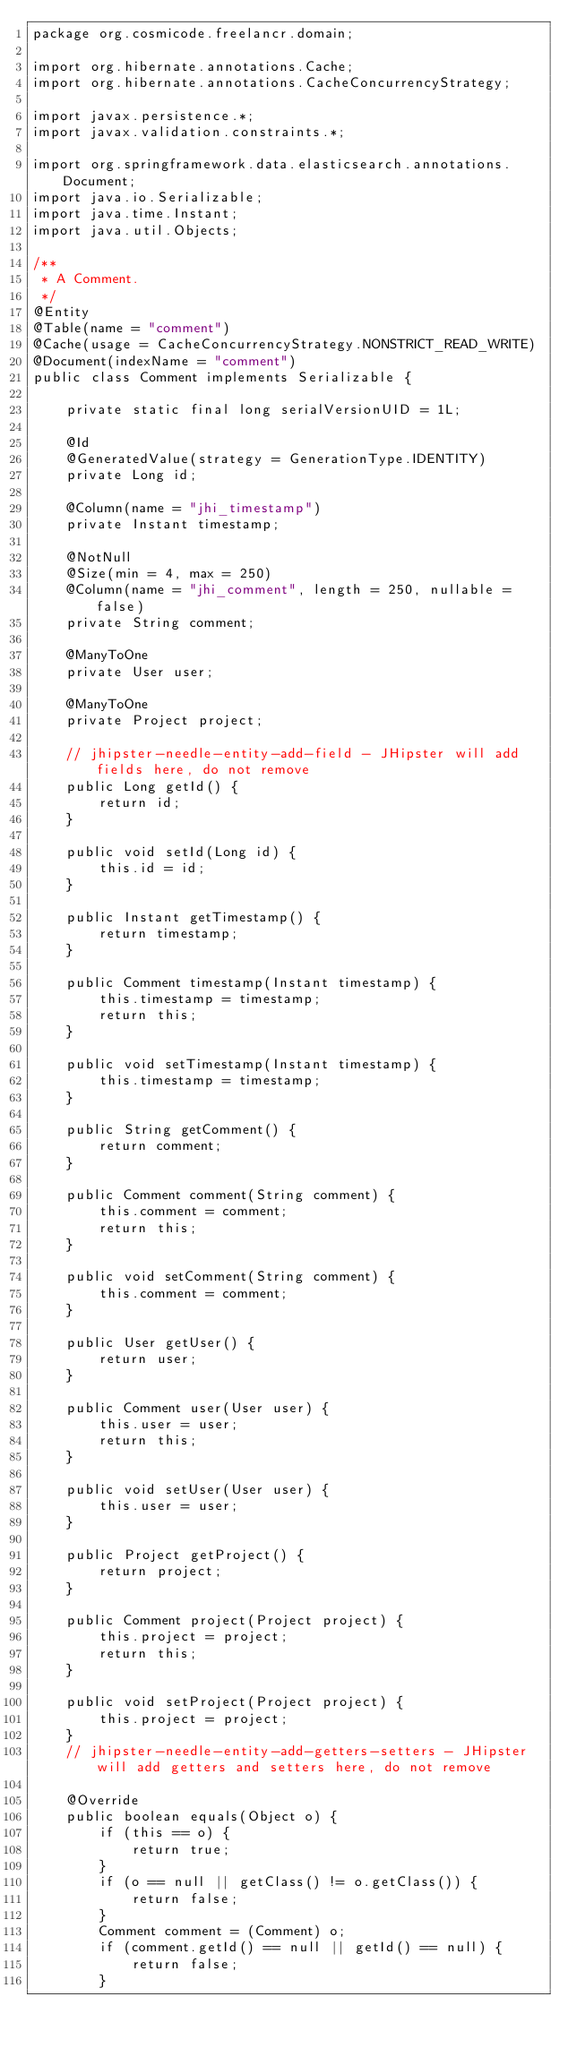Convert code to text. <code><loc_0><loc_0><loc_500><loc_500><_Java_>package org.cosmicode.freelancr.domain;

import org.hibernate.annotations.Cache;
import org.hibernate.annotations.CacheConcurrencyStrategy;

import javax.persistence.*;
import javax.validation.constraints.*;

import org.springframework.data.elasticsearch.annotations.Document;
import java.io.Serializable;
import java.time.Instant;
import java.util.Objects;

/**
 * A Comment.
 */
@Entity
@Table(name = "comment")
@Cache(usage = CacheConcurrencyStrategy.NONSTRICT_READ_WRITE)
@Document(indexName = "comment")
public class Comment implements Serializable {

    private static final long serialVersionUID = 1L;

    @Id
    @GeneratedValue(strategy = GenerationType.IDENTITY)
    private Long id;

    @Column(name = "jhi_timestamp")
    private Instant timestamp;

    @NotNull
    @Size(min = 4, max = 250)
    @Column(name = "jhi_comment", length = 250, nullable = false)
    private String comment;

    @ManyToOne
    private User user;

    @ManyToOne
    private Project project;

    // jhipster-needle-entity-add-field - JHipster will add fields here, do not remove
    public Long getId() {
        return id;
    }

    public void setId(Long id) {
        this.id = id;
    }

    public Instant getTimestamp() {
        return timestamp;
    }

    public Comment timestamp(Instant timestamp) {
        this.timestamp = timestamp;
        return this;
    }

    public void setTimestamp(Instant timestamp) {
        this.timestamp = timestamp;
    }

    public String getComment() {
        return comment;
    }

    public Comment comment(String comment) {
        this.comment = comment;
        return this;
    }

    public void setComment(String comment) {
        this.comment = comment;
    }

    public User getUser() {
        return user;
    }

    public Comment user(User user) {
        this.user = user;
        return this;
    }

    public void setUser(User user) {
        this.user = user;
    }

    public Project getProject() {
        return project;
    }

    public Comment project(Project project) {
        this.project = project;
        return this;
    }

    public void setProject(Project project) {
        this.project = project;
    }
    // jhipster-needle-entity-add-getters-setters - JHipster will add getters and setters here, do not remove

    @Override
    public boolean equals(Object o) {
        if (this == o) {
            return true;
        }
        if (o == null || getClass() != o.getClass()) {
            return false;
        }
        Comment comment = (Comment) o;
        if (comment.getId() == null || getId() == null) {
            return false;
        }</code> 